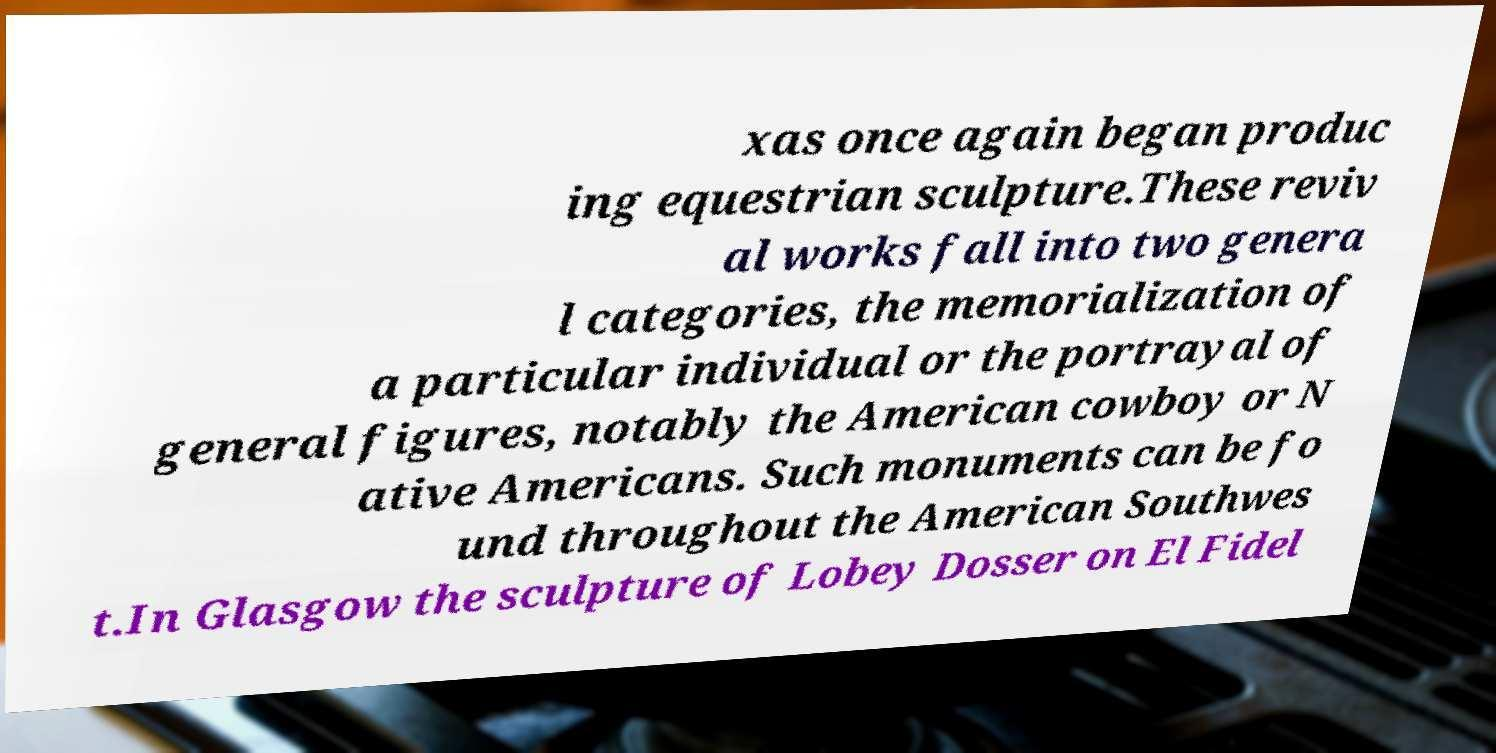Please identify and transcribe the text found in this image. xas once again began produc ing equestrian sculpture.These reviv al works fall into two genera l categories, the memorialization of a particular individual or the portrayal of general figures, notably the American cowboy or N ative Americans. Such monuments can be fo und throughout the American Southwes t.In Glasgow the sculpture of Lobey Dosser on El Fidel 